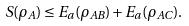<formula> <loc_0><loc_0><loc_500><loc_500>S ( \rho _ { A } ) \leq E _ { a } ( \rho _ { A B } ) + E _ { a } ( \rho _ { A C } ) .</formula> 